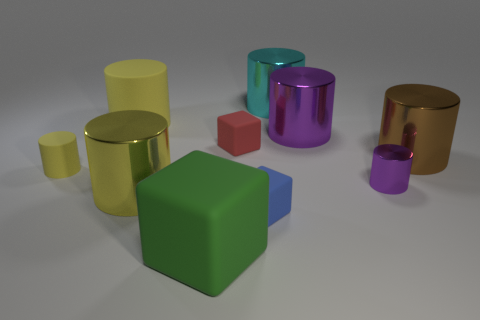Subtract all tiny cubes. How many cubes are left? 1 Subtract all brown balls. How many yellow cylinders are left? 3 Subtract all cyan cylinders. How many cylinders are left? 6 Subtract all cylinders. How many objects are left? 3 Add 7 tiny purple metal cylinders. How many tiny purple metal cylinders exist? 8 Subtract 0 gray balls. How many objects are left? 10 Subtract all blue cylinders. Subtract all gray spheres. How many cylinders are left? 7 Subtract all tiny yellow cubes. Subtract all tiny metal objects. How many objects are left? 9 Add 2 big brown shiny cylinders. How many big brown shiny cylinders are left? 3 